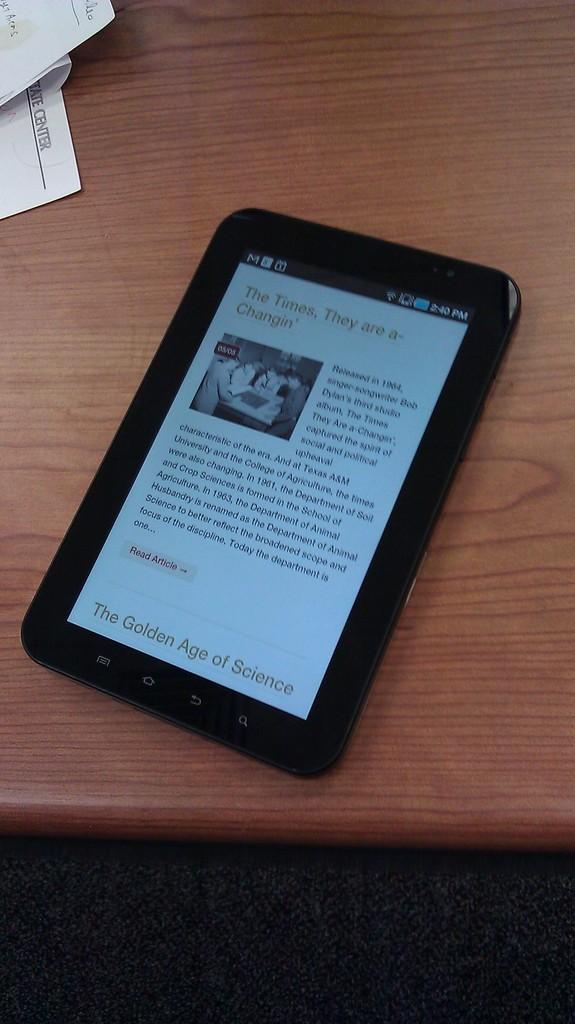Can you describe this image briefly? In this image there is a table on which there is a tablet pc. On the left side top there are papers on the table. 